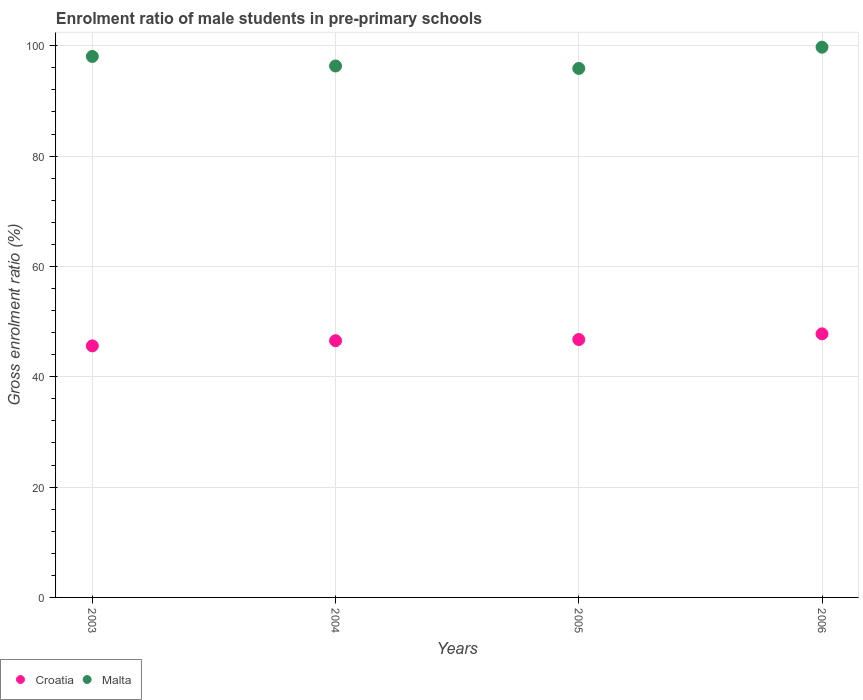What is the enrolment ratio of male students in pre-primary schools in Malta in 2006?
Your answer should be compact. 99.74. Across all years, what is the maximum enrolment ratio of male students in pre-primary schools in Malta?
Offer a very short reply. 99.74. Across all years, what is the minimum enrolment ratio of male students in pre-primary schools in Malta?
Your response must be concise. 95.89. In which year was the enrolment ratio of male students in pre-primary schools in Malta maximum?
Give a very brief answer. 2006. What is the total enrolment ratio of male students in pre-primary schools in Malta in the graph?
Ensure brevity in your answer.  390.04. What is the difference between the enrolment ratio of male students in pre-primary schools in Croatia in 2004 and that in 2006?
Provide a short and direct response. -1.24. What is the difference between the enrolment ratio of male students in pre-primary schools in Malta in 2004 and the enrolment ratio of male students in pre-primary schools in Croatia in 2005?
Provide a short and direct response. 49.59. What is the average enrolment ratio of male students in pre-primary schools in Croatia per year?
Provide a succinct answer. 46.67. In the year 2003, what is the difference between the enrolment ratio of male students in pre-primary schools in Malta and enrolment ratio of male students in pre-primary schools in Croatia?
Make the answer very short. 52.46. In how many years, is the enrolment ratio of male students in pre-primary schools in Malta greater than 52 %?
Give a very brief answer. 4. What is the ratio of the enrolment ratio of male students in pre-primary schools in Croatia in 2003 to that in 2005?
Make the answer very short. 0.98. Is the enrolment ratio of male students in pre-primary schools in Malta in 2003 less than that in 2006?
Your answer should be very brief. Yes. Is the difference between the enrolment ratio of male students in pre-primary schools in Malta in 2004 and 2005 greater than the difference between the enrolment ratio of male students in pre-primary schools in Croatia in 2004 and 2005?
Offer a terse response. Yes. What is the difference between the highest and the second highest enrolment ratio of male students in pre-primary schools in Malta?
Offer a terse response. 1.68. What is the difference between the highest and the lowest enrolment ratio of male students in pre-primary schools in Croatia?
Your answer should be compact. 2.18. In how many years, is the enrolment ratio of male students in pre-primary schools in Croatia greater than the average enrolment ratio of male students in pre-primary schools in Croatia taken over all years?
Keep it short and to the point. 2. Is the sum of the enrolment ratio of male students in pre-primary schools in Malta in 2003 and 2004 greater than the maximum enrolment ratio of male students in pre-primary schools in Croatia across all years?
Your answer should be compact. Yes. Does the enrolment ratio of male students in pre-primary schools in Croatia monotonically increase over the years?
Provide a short and direct response. Yes. How many dotlines are there?
Ensure brevity in your answer.  2. What is the difference between two consecutive major ticks on the Y-axis?
Provide a short and direct response. 20. Are the values on the major ticks of Y-axis written in scientific E-notation?
Make the answer very short. No. How many legend labels are there?
Your response must be concise. 2. How are the legend labels stacked?
Provide a short and direct response. Horizontal. What is the title of the graph?
Your response must be concise. Enrolment ratio of male students in pre-primary schools. Does "South Sudan" appear as one of the legend labels in the graph?
Provide a succinct answer. No. What is the label or title of the X-axis?
Make the answer very short. Years. What is the label or title of the Y-axis?
Your response must be concise. Gross enrolment ratio (%). What is the Gross enrolment ratio (%) in Croatia in 2003?
Provide a short and direct response. 45.6. What is the Gross enrolment ratio (%) in Malta in 2003?
Your response must be concise. 98.06. What is the Gross enrolment ratio (%) in Croatia in 2004?
Make the answer very short. 46.54. What is the Gross enrolment ratio (%) of Malta in 2004?
Keep it short and to the point. 96.34. What is the Gross enrolment ratio (%) in Croatia in 2005?
Provide a succinct answer. 46.75. What is the Gross enrolment ratio (%) of Malta in 2005?
Offer a very short reply. 95.89. What is the Gross enrolment ratio (%) in Croatia in 2006?
Offer a terse response. 47.78. What is the Gross enrolment ratio (%) of Malta in 2006?
Keep it short and to the point. 99.74. Across all years, what is the maximum Gross enrolment ratio (%) in Croatia?
Keep it short and to the point. 47.78. Across all years, what is the maximum Gross enrolment ratio (%) in Malta?
Offer a terse response. 99.74. Across all years, what is the minimum Gross enrolment ratio (%) in Croatia?
Your response must be concise. 45.6. Across all years, what is the minimum Gross enrolment ratio (%) of Malta?
Ensure brevity in your answer.  95.89. What is the total Gross enrolment ratio (%) in Croatia in the graph?
Give a very brief answer. 186.67. What is the total Gross enrolment ratio (%) in Malta in the graph?
Ensure brevity in your answer.  390.04. What is the difference between the Gross enrolment ratio (%) in Croatia in 2003 and that in 2004?
Offer a terse response. -0.94. What is the difference between the Gross enrolment ratio (%) in Malta in 2003 and that in 2004?
Your answer should be very brief. 1.73. What is the difference between the Gross enrolment ratio (%) of Croatia in 2003 and that in 2005?
Your answer should be very brief. -1.15. What is the difference between the Gross enrolment ratio (%) in Malta in 2003 and that in 2005?
Your answer should be compact. 2.18. What is the difference between the Gross enrolment ratio (%) in Croatia in 2003 and that in 2006?
Offer a very short reply. -2.18. What is the difference between the Gross enrolment ratio (%) of Malta in 2003 and that in 2006?
Make the answer very short. -1.68. What is the difference between the Gross enrolment ratio (%) of Croatia in 2004 and that in 2005?
Keep it short and to the point. -0.21. What is the difference between the Gross enrolment ratio (%) in Malta in 2004 and that in 2005?
Provide a succinct answer. 0.45. What is the difference between the Gross enrolment ratio (%) of Croatia in 2004 and that in 2006?
Your response must be concise. -1.24. What is the difference between the Gross enrolment ratio (%) in Malta in 2004 and that in 2006?
Your answer should be very brief. -3.41. What is the difference between the Gross enrolment ratio (%) of Croatia in 2005 and that in 2006?
Make the answer very short. -1.03. What is the difference between the Gross enrolment ratio (%) of Malta in 2005 and that in 2006?
Your response must be concise. -3.86. What is the difference between the Gross enrolment ratio (%) in Croatia in 2003 and the Gross enrolment ratio (%) in Malta in 2004?
Give a very brief answer. -50.74. What is the difference between the Gross enrolment ratio (%) of Croatia in 2003 and the Gross enrolment ratio (%) of Malta in 2005?
Make the answer very short. -50.29. What is the difference between the Gross enrolment ratio (%) in Croatia in 2003 and the Gross enrolment ratio (%) in Malta in 2006?
Your answer should be compact. -54.14. What is the difference between the Gross enrolment ratio (%) of Croatia in 2004 and the Gross enrolment ratio (%) of Malta in 2005?
Provide a short and direct response. -49.35. What is the difference between the Gross enrolment ratio (%) in Croatia in 2004 and the Gross enrolment ratio (%) in Malta in 2006?
Your answer should be very brief. -53.21. What is the difference between the Gross enrolment ratio (%) in Croatia in 2005 and the Gross enrolment ratio (%) in Malta in 2006?
Give a very brief answer. -53. What is the average Gross enrolment ratio (%) in Croatia per year?
Your response must be concise. 46.67. What is the average Gross enrolment ratio (%) in Malta per year?
Provide a succinct answer. 97.51. In the year 2003, what is the difference between the Gross enrolment ratio (%) of Croatia and Gross enrolment ratio (%) of Malta?
Offer a terse response. -52.46. In the year 2004, what is the difference between the Gross enrolment ratio (%) in Croatia and Gross enrolment ratio (%) in Malta?
Give a very brief answer. -49.8. In the year 2005, what is the difference between the Gross enrolment ratio (%) in Croatia and Gross enrolment ratio (%) in Malta?
Your answer should be compact. -49.14. In the year 2006, what is the difference between the Gross enrolment ratio (%) of Croatia and Gross enrolment ratio (%) of Malta?
Give a very brief answer. -51.97. What is the ratio of the Gross enrolment ratio (%) in Croatia in 2003 to that in 2004?
Provide a short and direct response. 0.98. What is the ratio of the Gross enrolment ratio (%) in Malta in 2003 to that in 2004?
Provide a short and direct response. 1.02. What is the ratio of the Gross enrolment ratio (%) in Croatia in 2003 to that in 2005?
Offer a terse response. 0.98. What is the ratio of the Gross enrolment ratio (%) in Malta in 2003 to that in 2005?
Provide a succinct answer. 1.02. What is the ratio of the Gross enrolment ratio (%) in Croatia in 2003 to that in 2006?
Your answer should be very brief. 0.95. What is the ratio of the Gross enrolment ratio (%) in Malta in 2003 to that in 2006?
Provide a succinct answer. 0.98. What is the ratio of the Gross enrolment ratio (%) in Malta in 2004 to that in 2005?
Your response must be concise. 1. What is the ratio of the Gross enrolment ratio (%) in Malta in 2004 to that in 2006?
Your answer should be compact. 0.97. What is the ratio of the Gross enrolment ratio (%) of Croatia in 2005 to that in 2006?
Offer a very short reply. 0.98. What is the ratio of the Gross enrolment ratio (%) of Malta in 2005 to that in 2006?
Your response must be concise. 0.96. What is the difference between the highest and the second highest Gross enrolment ratio (%) of Croatia?
Your answer should be compact. 1.03. What is the difference between the highest and the second highest Gross enrolment ratio (%) in Malta?
Offer a very short reply. 1.68. What is the difference between the highest and the lowest Gross enrolment ratio (%) of Croatia?
Offer a terse response. 2.18. What is the difference between the highest and the lowest Gross enrolment ratio (%) of Malta?
Offer a terse response. 3.86. 